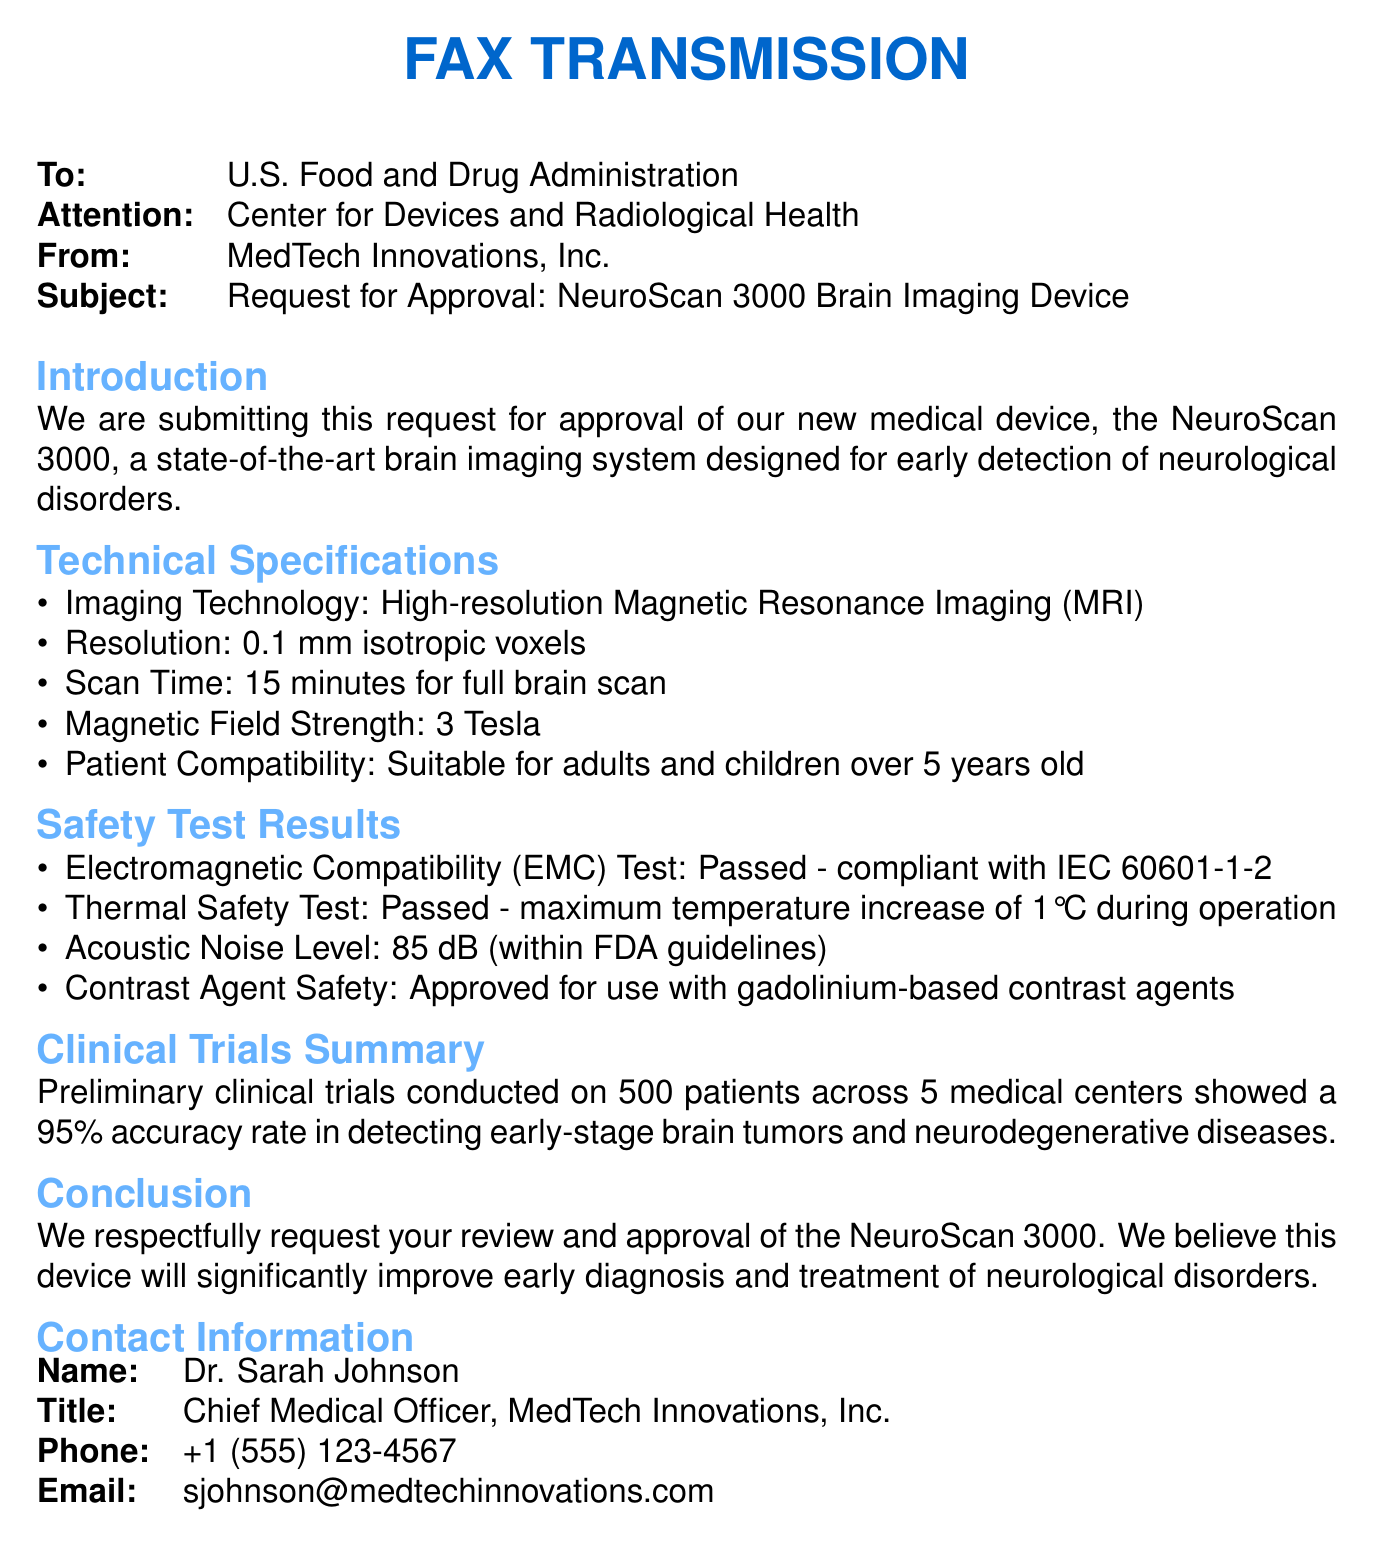What is the name of the device? The name of the device is mentioned in the document as NeuroScan 3000.
Answer: NeuroScan 3000 What is the magnetic field strength of the NeuroScan 3000? The document specifies the magnetic field strength of the device as 3 Tesla.
Answer: 3 Tesla How long does a full brain scan take? The scan time for a full brain scan is provided in the document, which is 15 minutes.
Answer: 15 minutes What is the contrast agent approved for use with the device? The document states that the device is approved for use with gadolinium-based contrast agents.
Answer: gadolinium-based contrast agents What was the accuracy rate of the preliminary clinical trials? The accuracy rate from the preliminary clinical trials, as stated in the document, is 95 percent.
Answer: 95 percent Which test did the NeuroScan 3000 pass regarding electromagnetic compatibility? The document mentions that the device passed the Electromagnetic Compatibility (EMC) Test compliant with IEC 60601-1-2.
Answer: IEC 60601-1-2 Who is the Chief Medical Officer of MedTech Innovations, Inc.? The document provides the name of the Chief Medical Officer as Dr. Sarah Johnson.
Answer: Dr. Sarah Johnson How many patients were included in the preliminary clinical trials? The document indicates that the preliminary clinical trials were conducted on 500 patients.
Answer: 500 patients What is the acoustic noise level of the device? The document specifies that the acoustic noise level is 85 dB.
Answer: 85 dB 